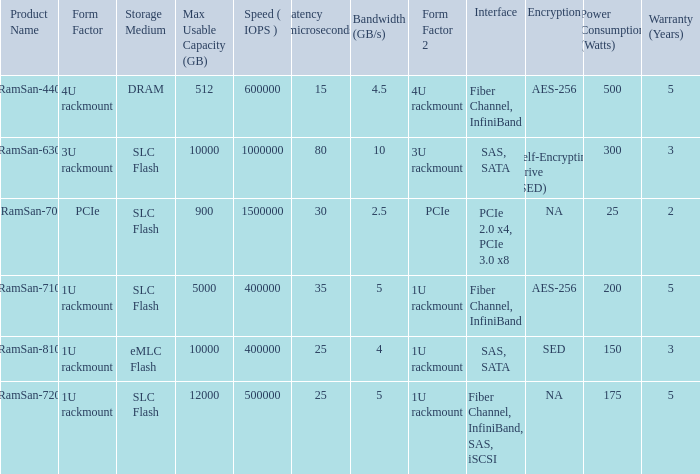List the range distroration for the ramsan-630 3U rackmount. 